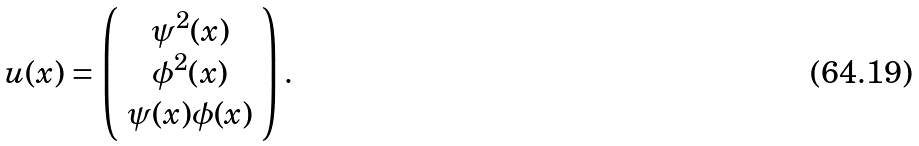<formula> <loc_0><loc_0><loc_500><loc_500>u ( x ) = \left ( \begin{array} { c } \psi ^ { 2 } ( x ) \\ \phi ^ { 2 } ( x ) \\ \psi ( x ) \phi ( x ) \end{array} \right ) .</formula> 